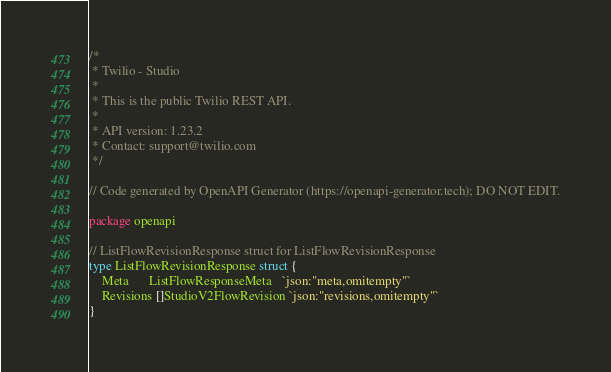<code> <loc_0><loc_0><loc_500><loc_500><_Go_>/*
 * Twilio - Studio
 *
 * This is the public Twilio REST API.
 *
 * API version: 1.23.2
 * Contact: support@twilio.com
 */

// Code generated by OpenAPI Generator (https://openapi-generator.tech); DO NOT EDIT.

package openapi

// ListFlowRevisionResponse struct for ListFlowRevisionResponse
type ListFlowRevisionResponse struct {
	Meta      ListFlowResponseMeta   `json:"meta,omitempty"`
	Revisions []StudioV2FlowRevision `json:"revisions,omitempty"`
}
</code> 